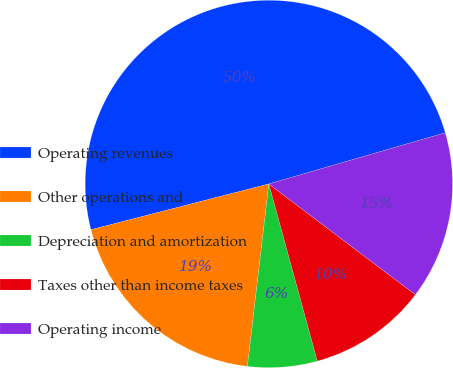<chart> <loc_0><loc_0><loc_500><loc_500><pie_chart><fcel>Operating revenues<fcel>Other operations and<fcel>Depreciation and amortization<fcel>Taxes other than income taxes<fcel>Operating income<nl><fcel>49.51%<fcel>19.13%<fcel>6.11%<fcel>10.45%<fcel>14.79%<nl></chart> 